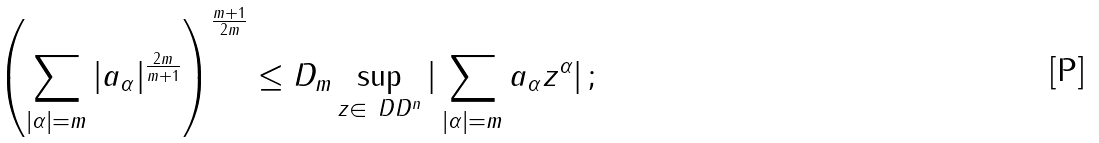<formula> <loc_0><loc_0><loc_500><loc_500>\left ( \sum _ { | \alpha | = m } | a _ { \alpha } | ^ { \frac { 2 m } { m + 1 } } \right ) ^ { \frac { m + 1 } { 2 m } } \leq D _ { m } \sup _ { z \in \ D D ^ { n } } | \sum _ { | \alpha | = m } a _ { \alpha } z ^ { \alpha } | \, ;</formula> 